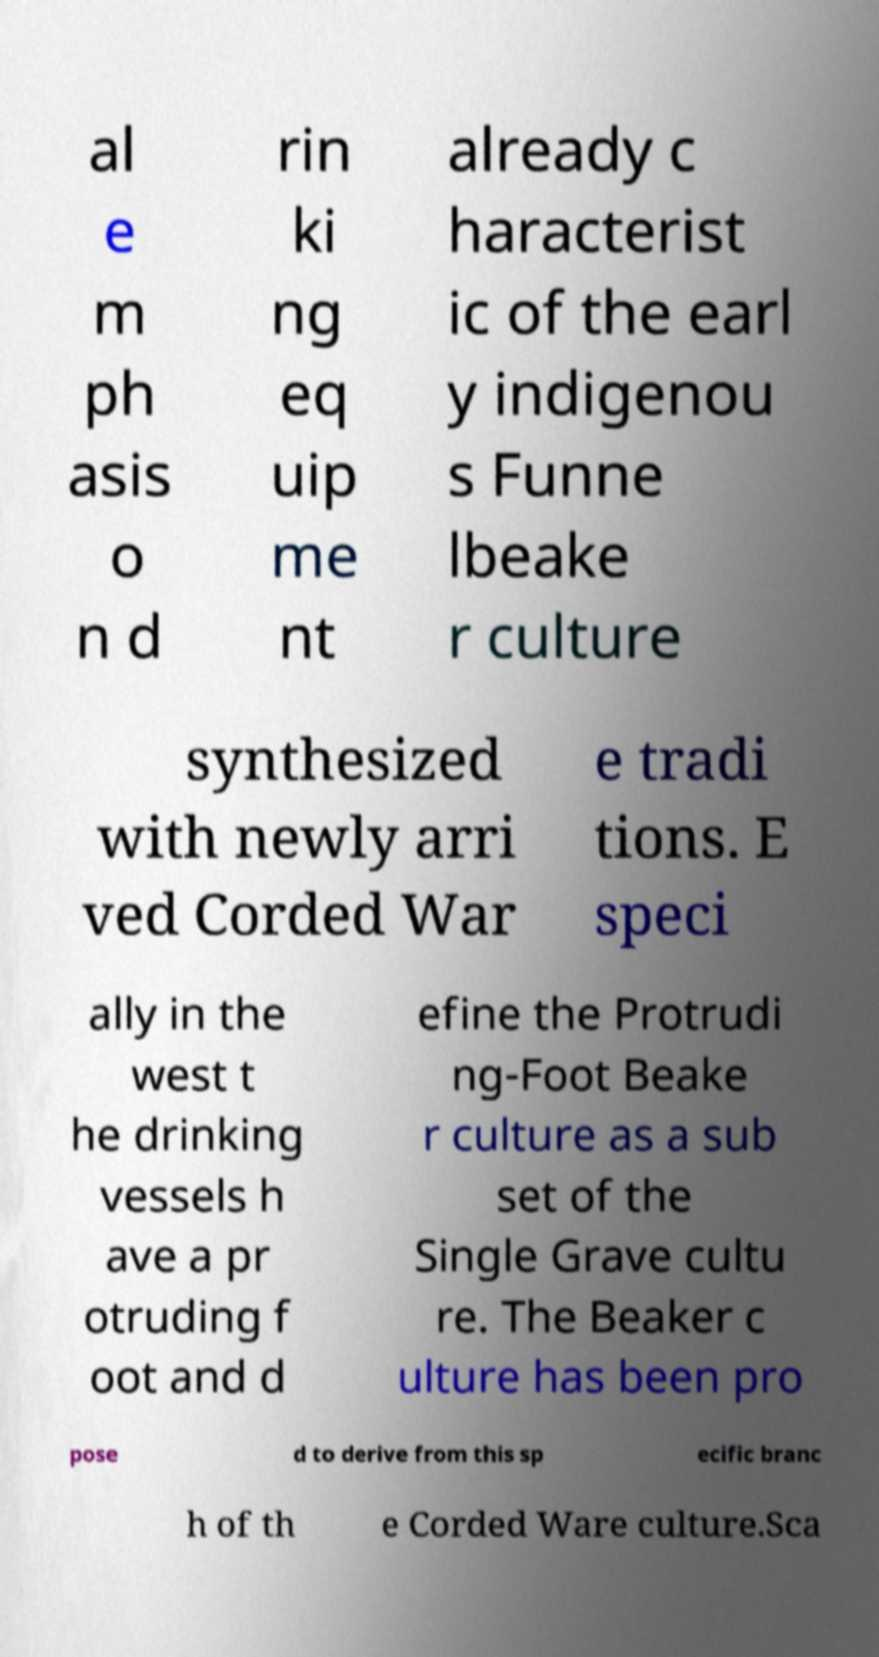For documentation purposes, I need the text within this image transcribed. Could you provide that? al e m ph asis o n d rin ki ng eq uip me nt already c haracterist ic of the earl y indigenou s Funne lbeake r culture synthesized with newly arri ved Corded War e tradi tions. E speci ally in the west t he drinking vessels h ave a pr otruding f oot and d efine the Protrudi ng-Foot Beake r culture as a sub set of the Single Grave cultu re. The Beaker c ulture has been pro pose d to derive from this sp ecific branc h of th e Corded Ware culture.Sca 